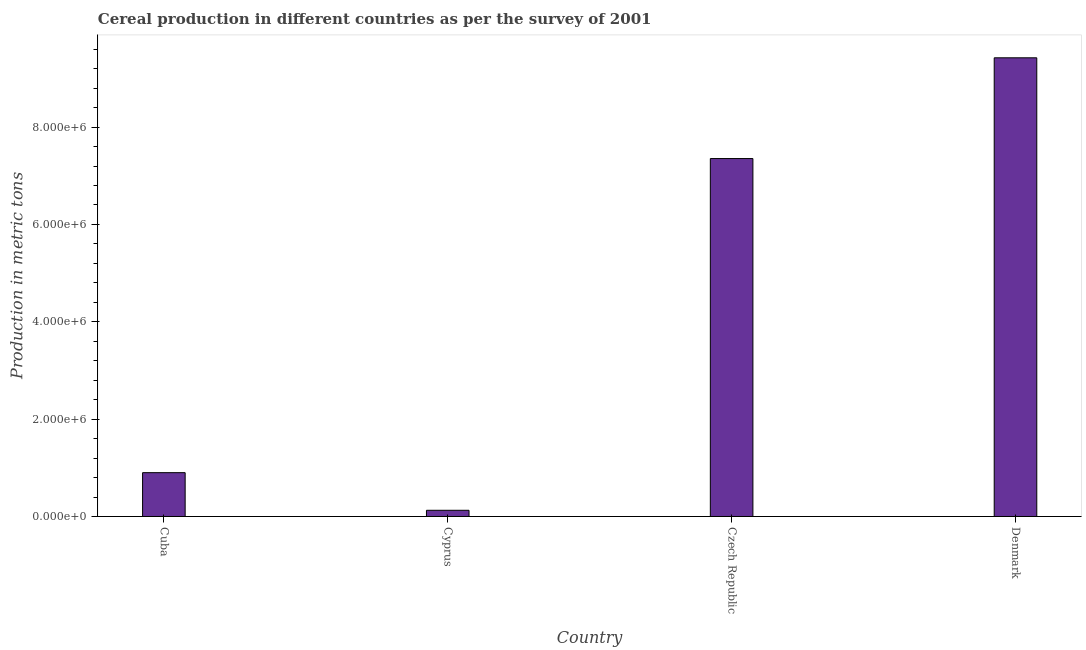Does the graph contain any zero values?
Ensure brevity in your answer.  No. Does the graph contain grids?
Your response must be concise. No. What is the title of the graph?
Offer a terse response. Cereal production in different countries as per the survey of 2001. What is the label or title of the X-axis?
Provide a succinct answer. Country. What is the label or title of the Y-axis?
Your answer should be very brief. Production in metric tons. What is the cereal production in Denmark?
Ensure brevity in your answer.  9.42e+06. Across all countries, what is the maximum cereal production?
Your answer should be compact. 9.42e+06. Across all countries, what is the minimum cereal production?
Ensure brevity in your answer.  1.27e+05. In which country was the cereal production maximum?
Offer a very short reply. Denmark. In which country was the cereal production minimum?
Your response must be concise. Cyprus. What is the sum of the cereal production?
Offer a very short reply. 1.78e+07. What is the difference between the cereal production in Cyprus and Czech Republic?
Provide a succinct answer. -7.23e+06. What is the average cereal production per country?
Provide a succinct answer. 4.45e+06. What is the median cereal production?
Offer a terse response. 4.13e+06. What is the ratio of the cereal production in Cyprus to that in Czech Republic?
Your answer should be compact. 0.02. Is the cereal production in Cyprus less than that in Denmark?
Offer a very short reply. Yes. Is the difference between the cereal production in Cyprus and Denmark greater than the difference between any two countries?
Offer a terse response. Yes. What is the difference between the highest and the second highest cereal production?
Provide a short and direct response. 2.07e+06. Is the sum of the cereal production in Czech Republic and Denmark greater than the maximum cereal production across all countries?
Your answer should be compact. Yes. What is the difference between the highest and the lowest cereal production?
Your answer should be very brief. 9.30e+06. How many bars are there?
Provide a succinct answer. 4. Are all the bars in the graph horizontal?
Your response must be concise. No. How many countries are there in the graph?
Your answer should be very brief. 4. Are the values on the major ticks of Y-axis written in scientific E-notation?
Keep it short and to the point. Yes. What is the Production in metric tons in Cuba?
Make the answer very short. 9.00e+05. What is the Production in metric tons in Cyprus?
Provide a short and direct response. 1.27e+05. What is the Production in metric tons of Czech Republic?
Provide a short and direct response. 7.35e+06. What is the Production in metric tons in Denmark?
Provide a succinct answer. 9.42e+06. What is the difference between the Production in metric tons in Cuba and Cyprus?
Make the answer very short. 7.73e+05. What is the difference between the Production in metric tons in Cuba and Czech Republic?
Provide a succinct answer. -6.45e+06. What is the difference between the Production in metric tons in Cuba and Denmark?
Provide a short and direct response. -8.52e+06. What is the difference between the Production in metric tons in Cyprus and Czech Republic?
Your response must be concise. -7.23e+06. What is the difference between the Production in metric tons in Cyprus and Denmark?
Keep it short and to the point. -9.30e+06. What is the difference between the Production in metric tons in Czech Republic and Denmark?
Keep it short and to the point. -2.07e+06. What is the ratio of the Production in metric tons in Cuba to that in Cyprus?
Provide a succinct answer. 7.07. What is the ratio of the Production in metric tons in Cuba to that in Czech Republic?
Offer a terse response. 0.12. What is the ratio of the Production in metric tons in Cuba to that in Denmark?
Ensure brevity in your answer.  0.1. What is the ratio of the Production in metric tons in Cyprus to that in Czech Republic?
Offer a very short reply. 0.02. What is the ratio of the Production in metric tons in Cyprus to that in Denmark?
Provide a succinct answer. 0.01. What is the ratio of the Production in metric tons in Czech Republic to that in Denmark?
Give a very brief answer. 0.78. 